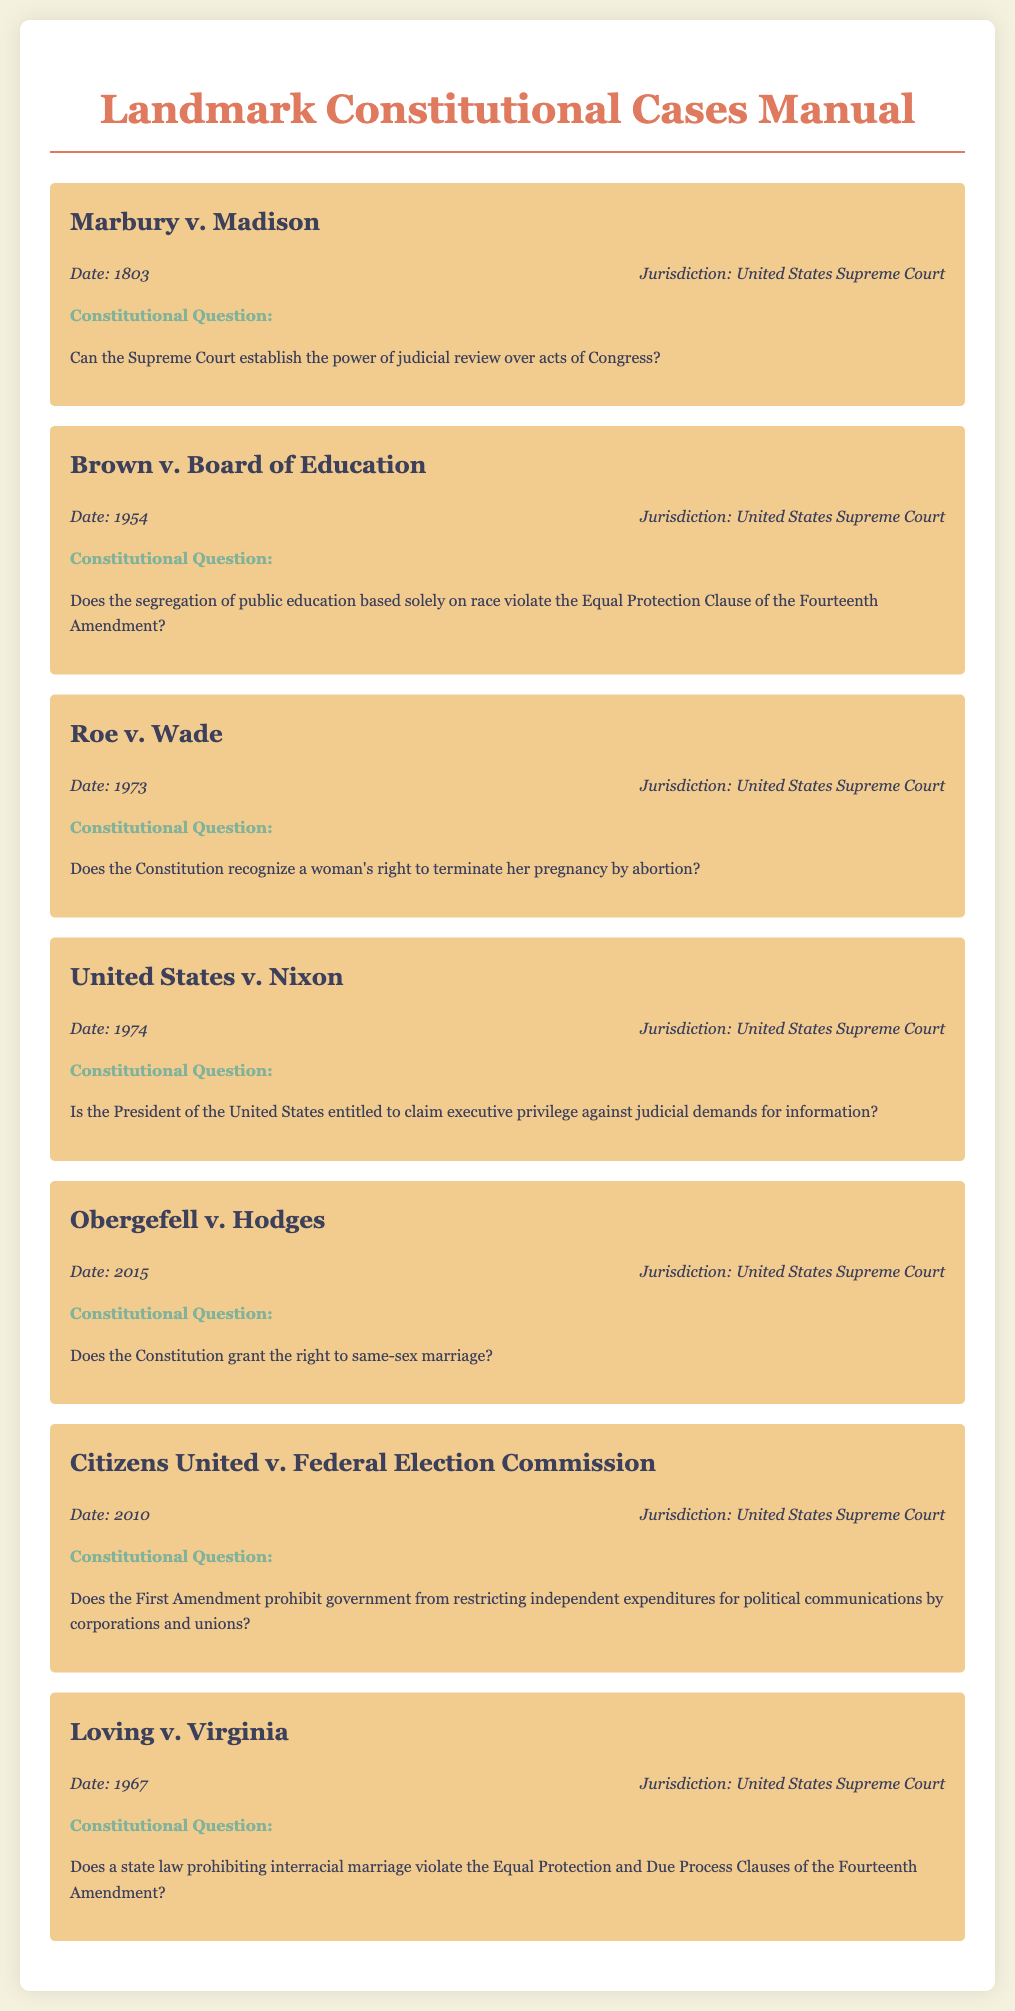What is the date of Marbury v. Madison? The date of Marbury v. Madison is provided in the document as the year it was decided, which is 1803.
Answer: 1803 What major constitutional question is addressed in Brown v. Board of Education? The document states that Brown v. Board of Education addresses whether segregation of public education based solely on race violates the Equal Protection Clause of the Fourteenth Amendment.
Answer: Equal Protection Clause of the Fourteenth Amendment Which case addresses the issue of same-sex marriage? Obergefell v. Hodges is listed as the case that addresses the issue of same-sex marriage in the document.
Answer: Obergefell v. Hodges What year was Roe v. Wade decided? The document provides a specific year for Roe v. Wade as part of its case information, which is 1973.
Answer: 1973 In which jurisdiction was United States v. Nixon decided? The jurisdiction for United States v. Nixon is noted in the document as the United States Supreme Court.
Answer: United States Supreme Court What constitutional question does Citizens United v. Federal Election Commission focus on? The document indicates that Citizens United v. Federal Election Commission focuses on whether the First Amendment prohibits government from restricting independent expenditures for political communications by corporations and unions.
Answer: First Amendment What is the key constitutional issue in Loving v. Virginia? The document highlights that Loving v. Virginia questions whether a state law prohibiting interracial marriage violates the Equal Protection and Due Process Clauses of the Fourteenth Amendment.
Answer: Equal Protection and Due Process Clauses of the Fourteenth Amendment What type of document is this? The document is explicitly titled as a "Landmark Constitutional Cases Manual."
Answer: Landmark Constitutional Cases Manual 